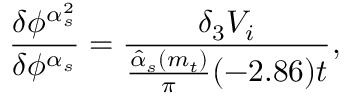Convert formula to latex. <formula><loc_0><loc_0><loc_500><loc_500>\frac { \delta \phi ^ { \alpha _ { s } ^ { 2 } } } { \delta \phi ^ { \alpha _ { s } } } = \frac { \delta _ { 3 } V _ { i } } { \frac { \hat { \alpha } _ { s } ( m _ { t } ) } { \pi } ( - 2 . 8 6 ) t } ,</formula> 